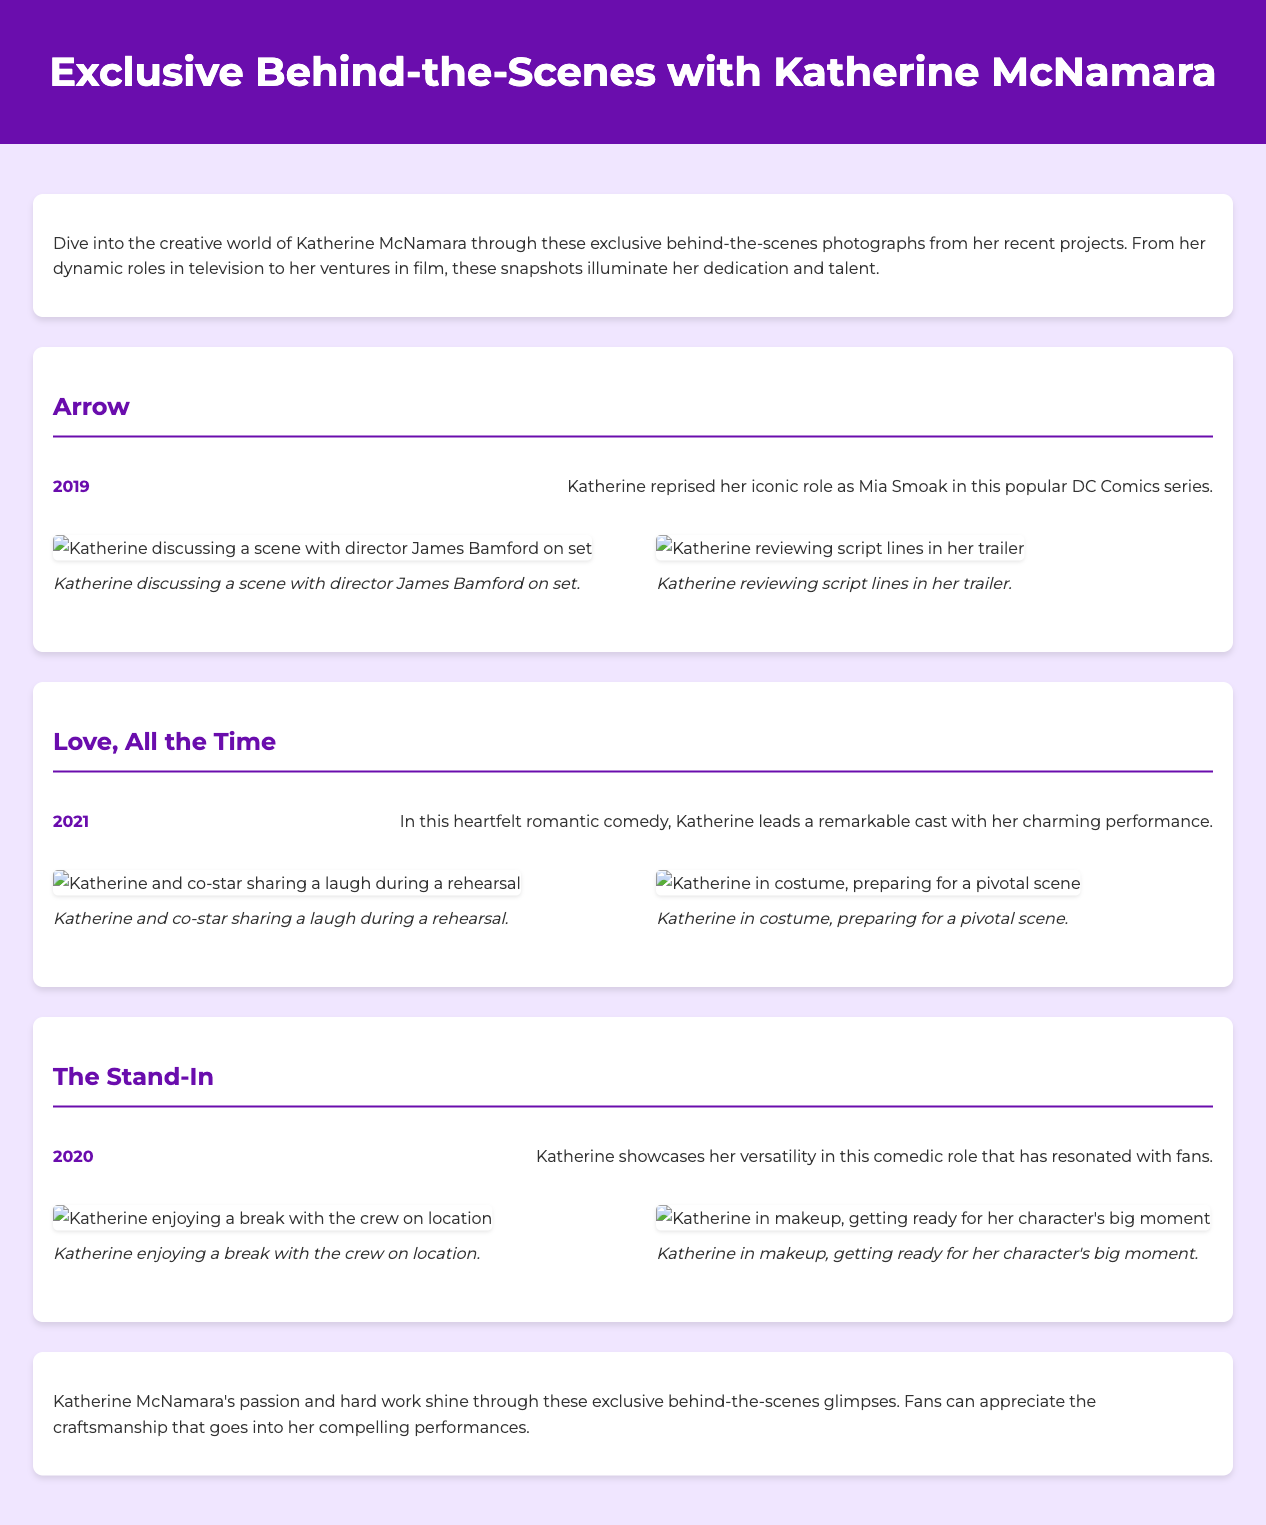what is the title of the catalog? The title of the catalog is presented in the header of the document.
Answer: Exclusive Behind-the-Scenes with Katherine McNamara how many projects are featured in the document? The document lists three projects under the behind-the-scenes photographs.
Answer: 3 what year was "Love, All the Time" released? The year of release for "Love, All the Time" is mentioned in the project section.
Answer: 2021 who directed "Arrow"? The name of the director is mentioned in the first project section.
Answer: James Bamford what character does Katherine portray in "Arrow"? The character name is specified in the project description for "Arrow."
Answer: Mia Smoak what is Katherine doing in the photo where she is reviewing script lines? The description under the photograph specifies her activity on set.
Answer: Reviewing script lines which project features Katherine in makeup? The project description states her activity related to makeup in one of the sections.
Answer: The Stand-In what is the color of the header background? The background color of the header is described in the styling section of the document.
Answer: #6a0dad 